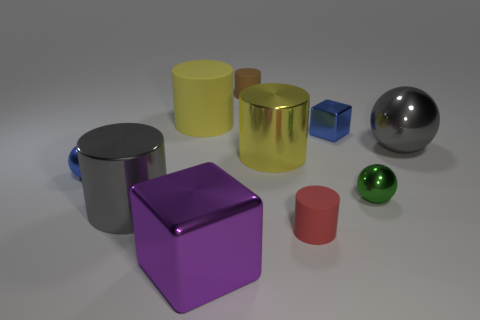Subtract all red rubber cylinders. How many cylinders are left? 4 Subtract all red cylinders. How many cylinders are left? 4 Subtract all blue cylinders. Subtract all purple balls. How many cylinders are left? 5 Subtract all balls. How many objects are left? 7 Add 4 blue cubes. How many blue cubes are left? 5 Add 1 green metallic objects. How many green metallic objects exist? 2 Subtract 0 purple cylinders. How many objects are left? 10 Subtract all blue cubes. Subtract all yellow rubber cylinders. How many objects are left? 8 